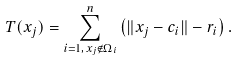Convert formula to latex. <formula><loc_0><loc_0><loc_500><loc_500>T ( x _ { j } ) = \sum _ { i = 1 , \, x _ { j } \notin \Omega _ { i } } ^ { n } \left ( \| x _ { j } - c _ { i } \| - r _ { i } \right ) .</formula> 